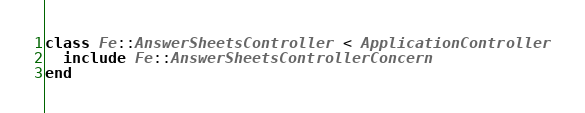Convert code to text. <code><loc_0><loc_0><loc_500><loc_500><_Ruby_>class Fe::AnswerSheetsController < ApplicationController
  include Fe::AnswerSheetsControllerConcern
end
</code> 